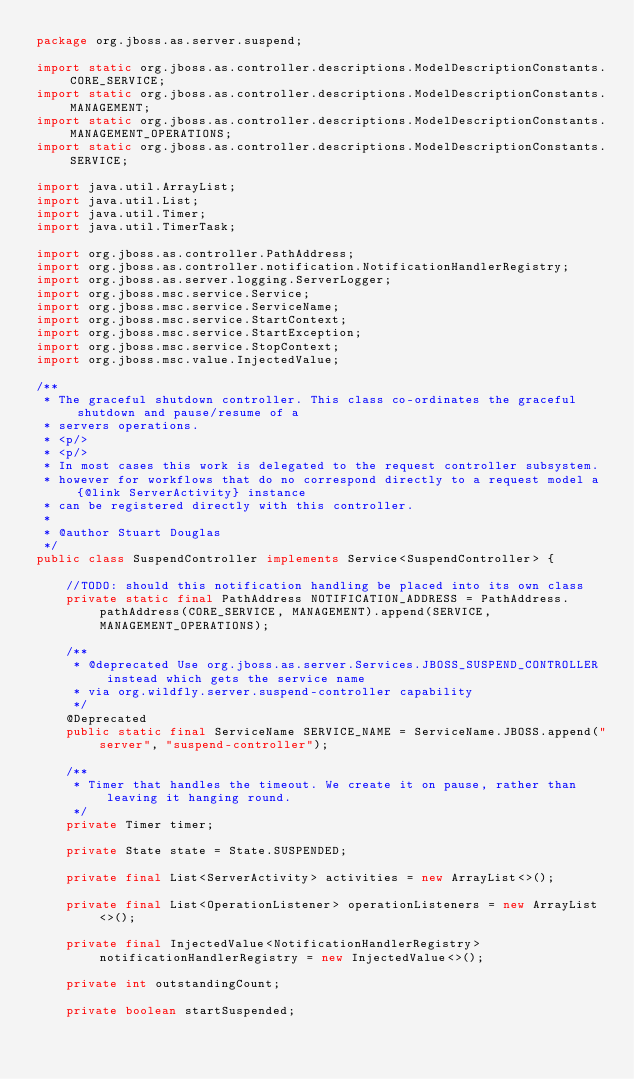Convert code to text. <code><loc_0><loc_0><loc_500><loc_500><_Java_>package org.jboss.as.server.suspend;

import static org.jboss.as.controller.descriptions.ModelDescriptionConstants.CORE_SERVICE;
import static org.jboss.as.controller.descriptions.ModelDescriptionConstants.MANAGEMENT;
import static org.jboss.as.controller.descriptions.ModelDescriptionConstants.MANAGEMENT_OPERATIONS;
import static org.jboss.as.controller.descriptions.ModelDescriptionConstants.SERVICE;

import java.util.ArrayList;
import java.util.List;
import java.util.Timer;
import java.util.TimerTask;

import org.jboss.as.controller.PathAddress;
import org.jboss.as.controller.notification.NotificationHandlerRegistry;
import org.jboss.as.server.logging.ServerLogger;
import org.jboss.msc.service.Service;
import org.jboss.msc.service.ServiceName;
import org.jboss.msc.service.StartContext;
import org.jboss.msc.service.StartException;
import org.jboss.msc.service.StopContext;
import org.jboss.msc.value.InjectedValue;

/**
 * The graceful shutdown controller. This class co-ordinates the graceful shutdown and pause/resume of a
 * servers operations.
 * <p/>
 * <p/>
 * In most cases this work is delegated to the request controller subsystem.
 * however for workflows that do no correspond directly to a request model a {@link ServerActivity} instance
 * can be registered directly with this controller.
 *
 * @author Stuart Douglas
 */
public class SuspendController implements Service<SuspendController> {

    //TODO: should this notification handling be placed into its own class
    private static final PathAddress NOTIFICATION_ADDRESS = PathAddress.pathAddress(CORE_SERVICE, MANAGEMENT).append(SERVICE, MANAGEMENT_OPERATIONS);

    /**
     * @deprecated Use org.jboss.as.server.Services.JBOSS_SUSPEND_CONTROLLER instead which gets the service name
     * via org.wildfly.server.suspend-controller capability
     */
    @Deprecated
    public static final ServiceName SERVICE_NAME = ServiceName.JBOSS.append("server", "suspend-controller");

    /**
     * Timer that handles the timeout. We create it on pause, rather than leaving it hanging round.
     */
    private Timer timer;

    private State state = State.SUSPENDED;

    private final List<ServerActivity> activities = new ArrayList<>();

    private final List<OperationListener> operationListeners = new ArrayList<>();

    private final InjectedValue<NotificationHandlerRegistry> notificationHandlerRegistry = new InjectedValue<>();

    private int outstandingCount;

    private boolean startSuspended;
</code> 